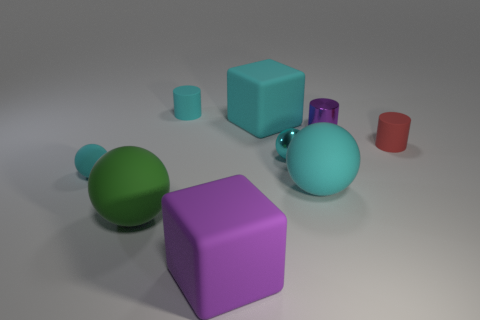Does the green sphere have the same material as the purple object that is to the right of the shiny sphere?
Offer a very short reply. No. What is the size of the purple object behind the large purple rubber cube?
Keep it short and to the point. Small. Are there fewer shiny balls than cubes?
Make the answer very short. Yes. Are there any shiny objects that have the same color as the tiny matte ball?
Offer a very short reply. Yes. What is the shape of the large object that is both in front of the purple metal cylinder and behind the green ball?
Your answer should be compact. Sphere. There is a cyan matte object that is in front of the small cyan rubber object in front of the large cyan rubber block; what shape is it?
Your answer should be compact. Sphere. Is the purple metal object the same shape as the tiny red object?
Offer a very short reply. Yes. There is a cube that is the same color as the metallic ball; what material is it?
Offer a very short reply. Rubber. Do the small metallic ball and the tiny matte sphere have the same color?
Make the answer very short. Yes. What number of large cyan objects are on the left side of the cyan object left of the tiny matte cylinder behind the big cyan rubber block?
Offer a terse response. 0. 